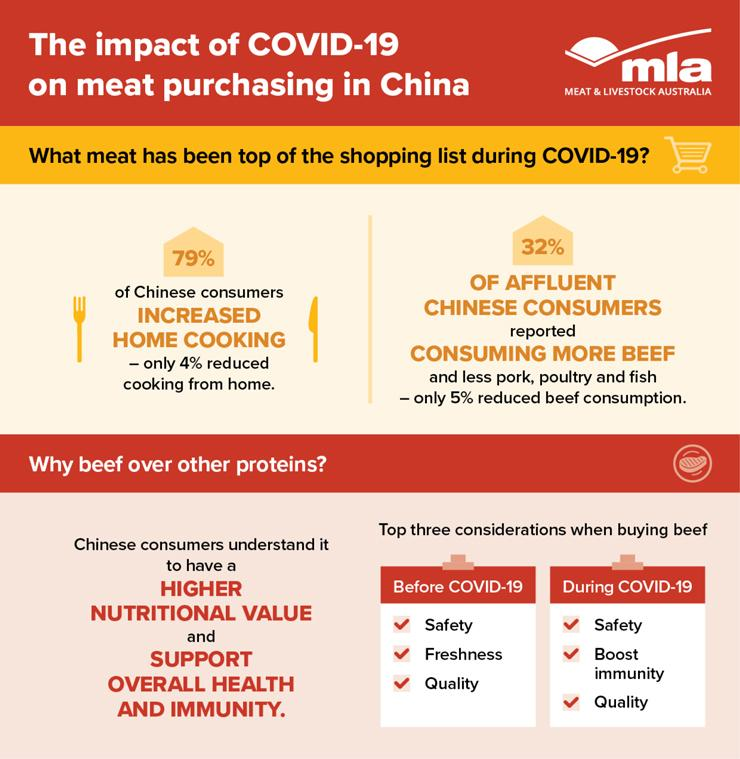List a handful of essential elements in this visual. During the COVID-19 pandemic, beef has been consumed in the highest quantity among all types of meat. The consideration of quality remained constant before and after the COVID-19 pandemic in regard to construction projects, despite safety being a top priority. According to a recent survey, 68% of Chinese individuals did not increase their consumption of beef. 